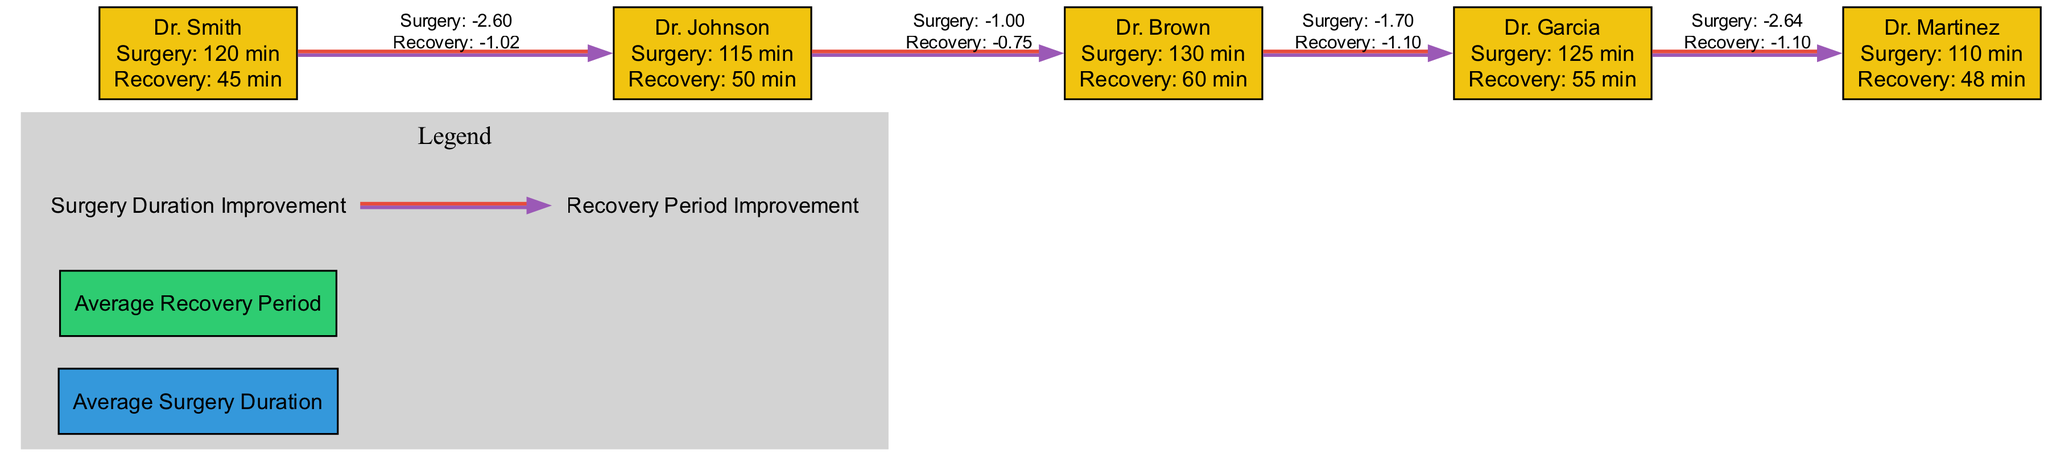What is the average surgery duration for Dr. Johnson? The metric for Dr. Johnson's average surgery duration is specified in the diagram, which shows it as 115 minutes.
Answer: 115 minutes Which anesthesiologist has the longest recovery period? By comparing the recovery periods listed for each anesthesiologist, Dr. Brown's recovery period of 60 minutes is the highest among the group.
Answer: Dr. Brown How many anesthesiologists are represented in the diagram? The data section lists five anesthesiologists: Dr. Smith, Dr. Johnson, Dr. Brown, Dr. Garcia, and Dr. Martinez, indicating that there are a total of five.
Answer: Five What trend indicates improvement in surgery duration for Dr. Garcia? The trend line data for Dr. Garcia shows an average improvement in surgery duration over time, specifically averaging around -1.5, which indicates a decline in time taken.
Answer: Average improvement of -1.5 What is the average recovery period for Dr. Smith? The recovery period data for Dr. Smith shows a duration of 45 minutes, which is clearly indicated in the corresponding section of the diagram.
Answer: 45 minutes Which anesthesiologist shows the greatest decline in recovery period? Analyzing the recovery period trend data reveals that Dr. Brown maintains a steady decline of approximately -0.9 on average, indicating substantial improvement compared to others.
Answer: Dr. Brown What color represents Average Surgery Duration in the legend? The diagram's legend highlights that the Average Surgery Duration is represented in the color blue, specifically noted as #3498db.
Answer: Blue How does Dr. Martinez compare to Dr. Smith in terms of surgery duration? Dr. Martinez has an average surgery duration of 110 minutes compared to Dr. Smith's 120 minutes, indicating Dr. Martinez performs surgery quicker on average.
Answer: Quicker What is the trend line color representing Recovery Period Improvement? The trend line demonstrating Recovery Period Improvement is represented in the diagram by a red color, designated as #e74c3c.
Answer: Red 